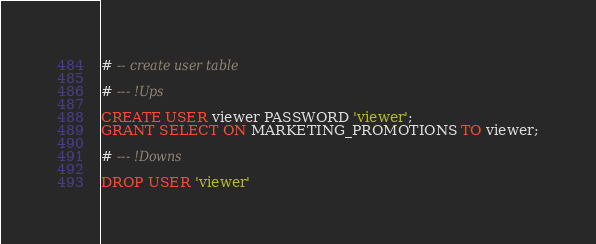<code> <loc_0><loc_0><loc_500><loc_500><_SQL_># -- create user table

# --- !Ups

CREATE USER viewer PASSWORD 'viewer';
GRANT SELECT ON MARKETING_PROMOTIONS TO viewer;

# --- !Downs

DROP USER 'viewer'
</code> 